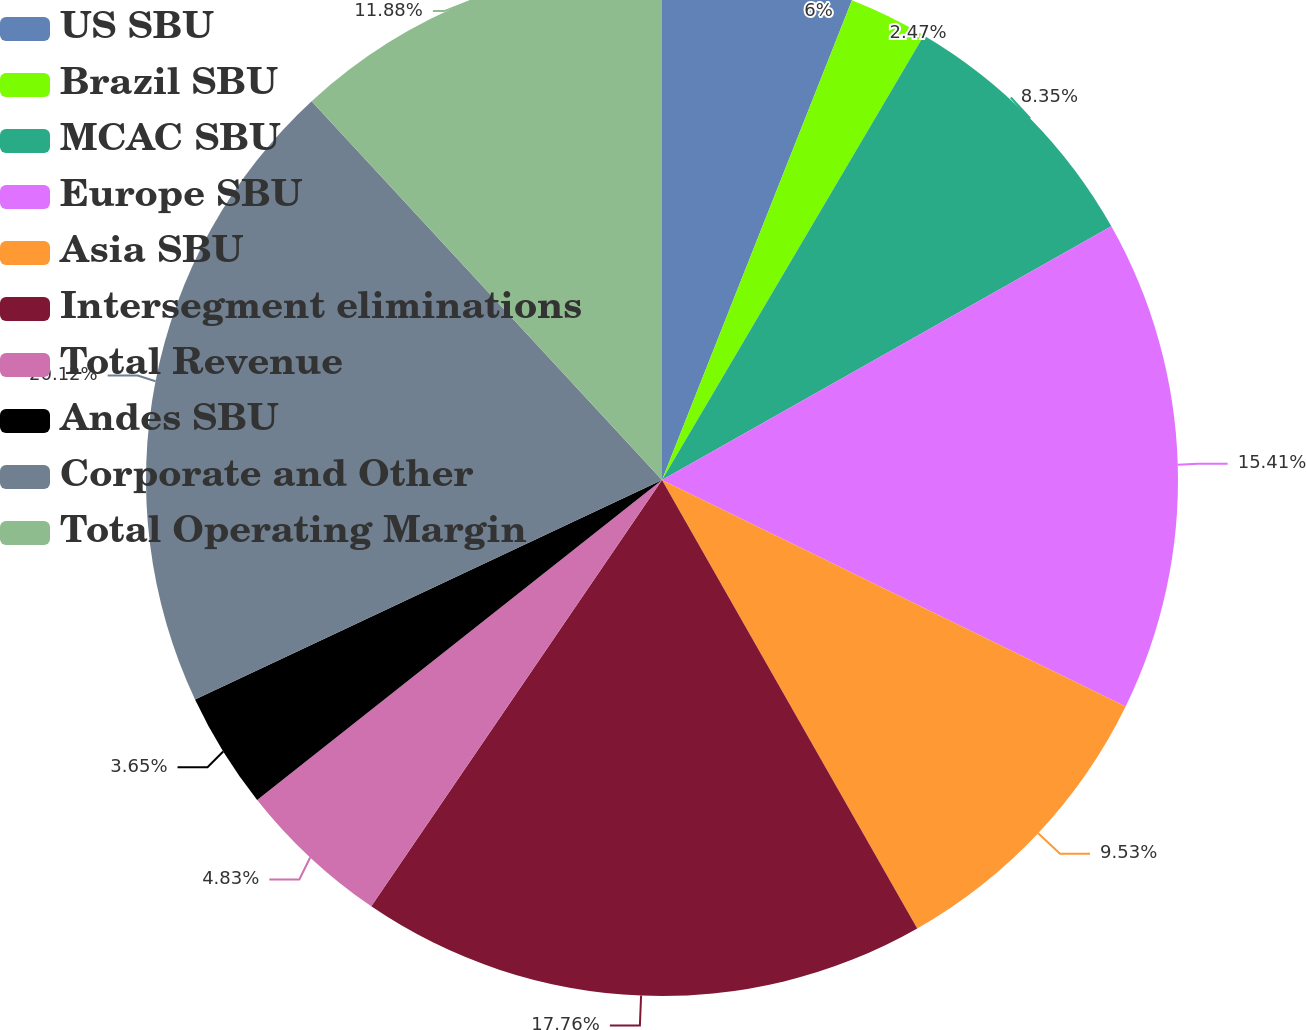Convert chart to OTSL. <chart><loc_0><loc_0><loc_500><loc_500><pie_chart><fcel>US SBU<fcel>Brazil SBU<fcel>MCAC SBU<fcel>Europe SBU<fcel>Asia SBU<fcel>Intersegment eliminations<fcel>Total Revenue<fcel>Andes SBU<fcel>Corporate and Other<fcel>Total Operating Margin<nl><fcel>6.0%<fcel>2.47%<fcel>8.35%<fcel>15.41%<fcel>9.53%<fcel>17.76%<fcel>4.83%<fcel>3.65%<fcel>20.11%<fcel>11.88%<nl></chart> 